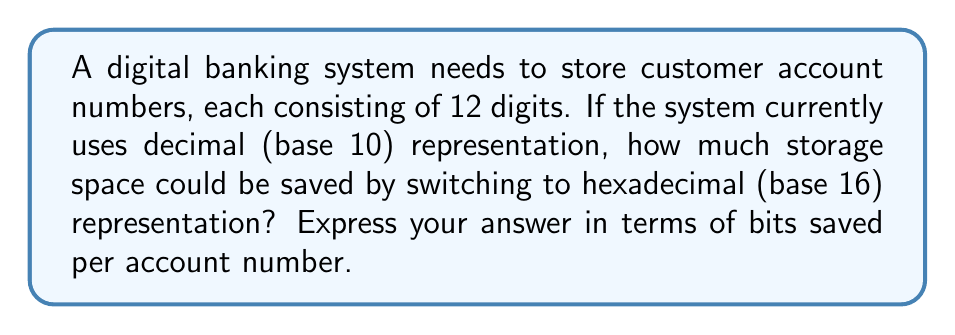Can you solve this math problem? To solve this problem, we need to compare the storage requirements for decimal and hexadecimal representations of the account numbers.

1. Decimal (base 10) representation:
   - Each digit can be one of 10 possibilities (0-9)
   - We need $\log_2(10)$ bits to represent each digit
   - For 12 digits: $12 \times \log_2(10) \approx 39.86$ bits

2. Hexadecimal (base 16) representation:
   - Each hexadecimal digit represents 4 bits
   - 12 decimal digits can be represented by $\lceil 12 \times \log_{16}(10) \rceil = 10$ hexadecimal digits
   - Total bits required: $10 \times 4 = 40$ bits

3. Calculate the difference:
   $39.86 - 40 = -0.14$ bits

The negative result indicates that hexadecimal representation actually requires slightly more storage space. This is because 12 decimal digits don't align perfectly with hexadecimal representation, causing some wasted space.

To optimize storage, we can consider using binary representation directly:
   - 12 decimal digits can represent up to $10^{12}$ unique numbers
   - In binary, we need $\lceil \log_2(10^{12}) \rceil = 40$ bits

Therefore, using binary representation instead of decimal would save:
$39.86 - 40 = -0.14$ bits per account number (rounded to 2 decimal places)
Answer: $-0.14$ bits saved per account number 